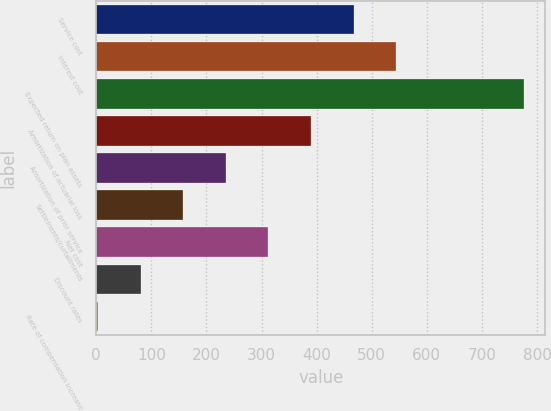Convert chart to OTSL. <chart><loc_0><loc_0><loc_500><loc_500><bar_chart><fcel>Service cost<fcel>Interest cost<fcel>Expected return on plan assets<fcel>Amortization of actuarial loss<fcel>Amortization of prior service<fcel>Settlements/curtailments<fcel>Net cost<fcel>Discount rates<fcel>Rate of compensation increase<nl><fcel>467.12<fcel>544.34<fcel>776<fcel>389.9<fcel>235.46<fcel>158.24<fcel>312.68<fcel>81.02<fcel>3.8<nl></chart> 